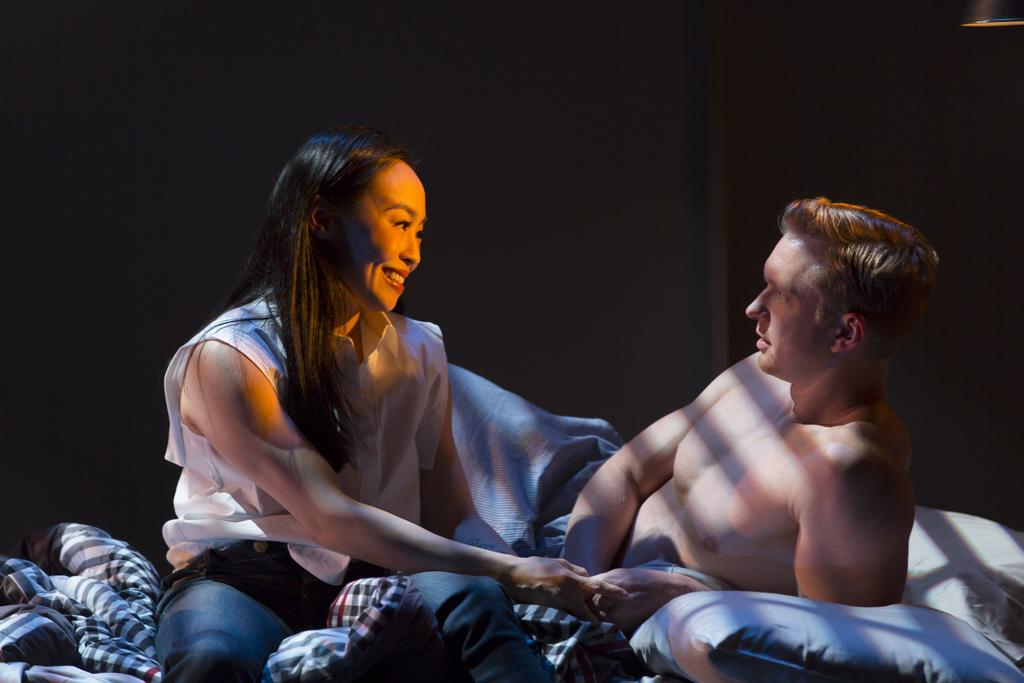What is happening on the bed in the image? There are people on the bed. What covers the bed in the image? Bedsheets are present on the bed. What are the people using for support or comfort? Pillows are on the bed. What can be seen at the top of the image? There is a light at the top of the image. How would you describe the overall lighting in the image? The background of the image is dark. How does the island help the people on the bed in the image? There is no island present in the image; it features people on a bed with bedsheets and pillows. What type of stretch can be seen on the bed in the image? There is no stretch visible on the bed in the image; it features people lying down or sitting on the bed. 